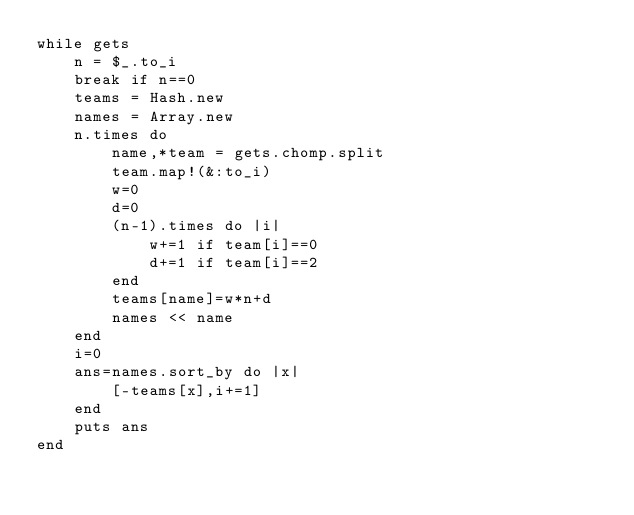<code> <loc_0><loc_0><loc_500><loc_500><_Ruby_>while gets
    n = $_.to_i
    break if n==0
    teams = Hash.new
    names = Array.new
    n.times do
        name,*team = gets.chomp.split
        team.map!(&:to_i)
        w=0
        d=0
        (n-1).times do |i|
            w+=1 if team[i]==0
            d+=1 if team[i]==2
        end
        teams[name]=w*n+d
        names << name
    end
    i=0
    ans=names.sort_by do |x|
        [-teams[x],i+=1]
    end
    puts ans
end</code> 